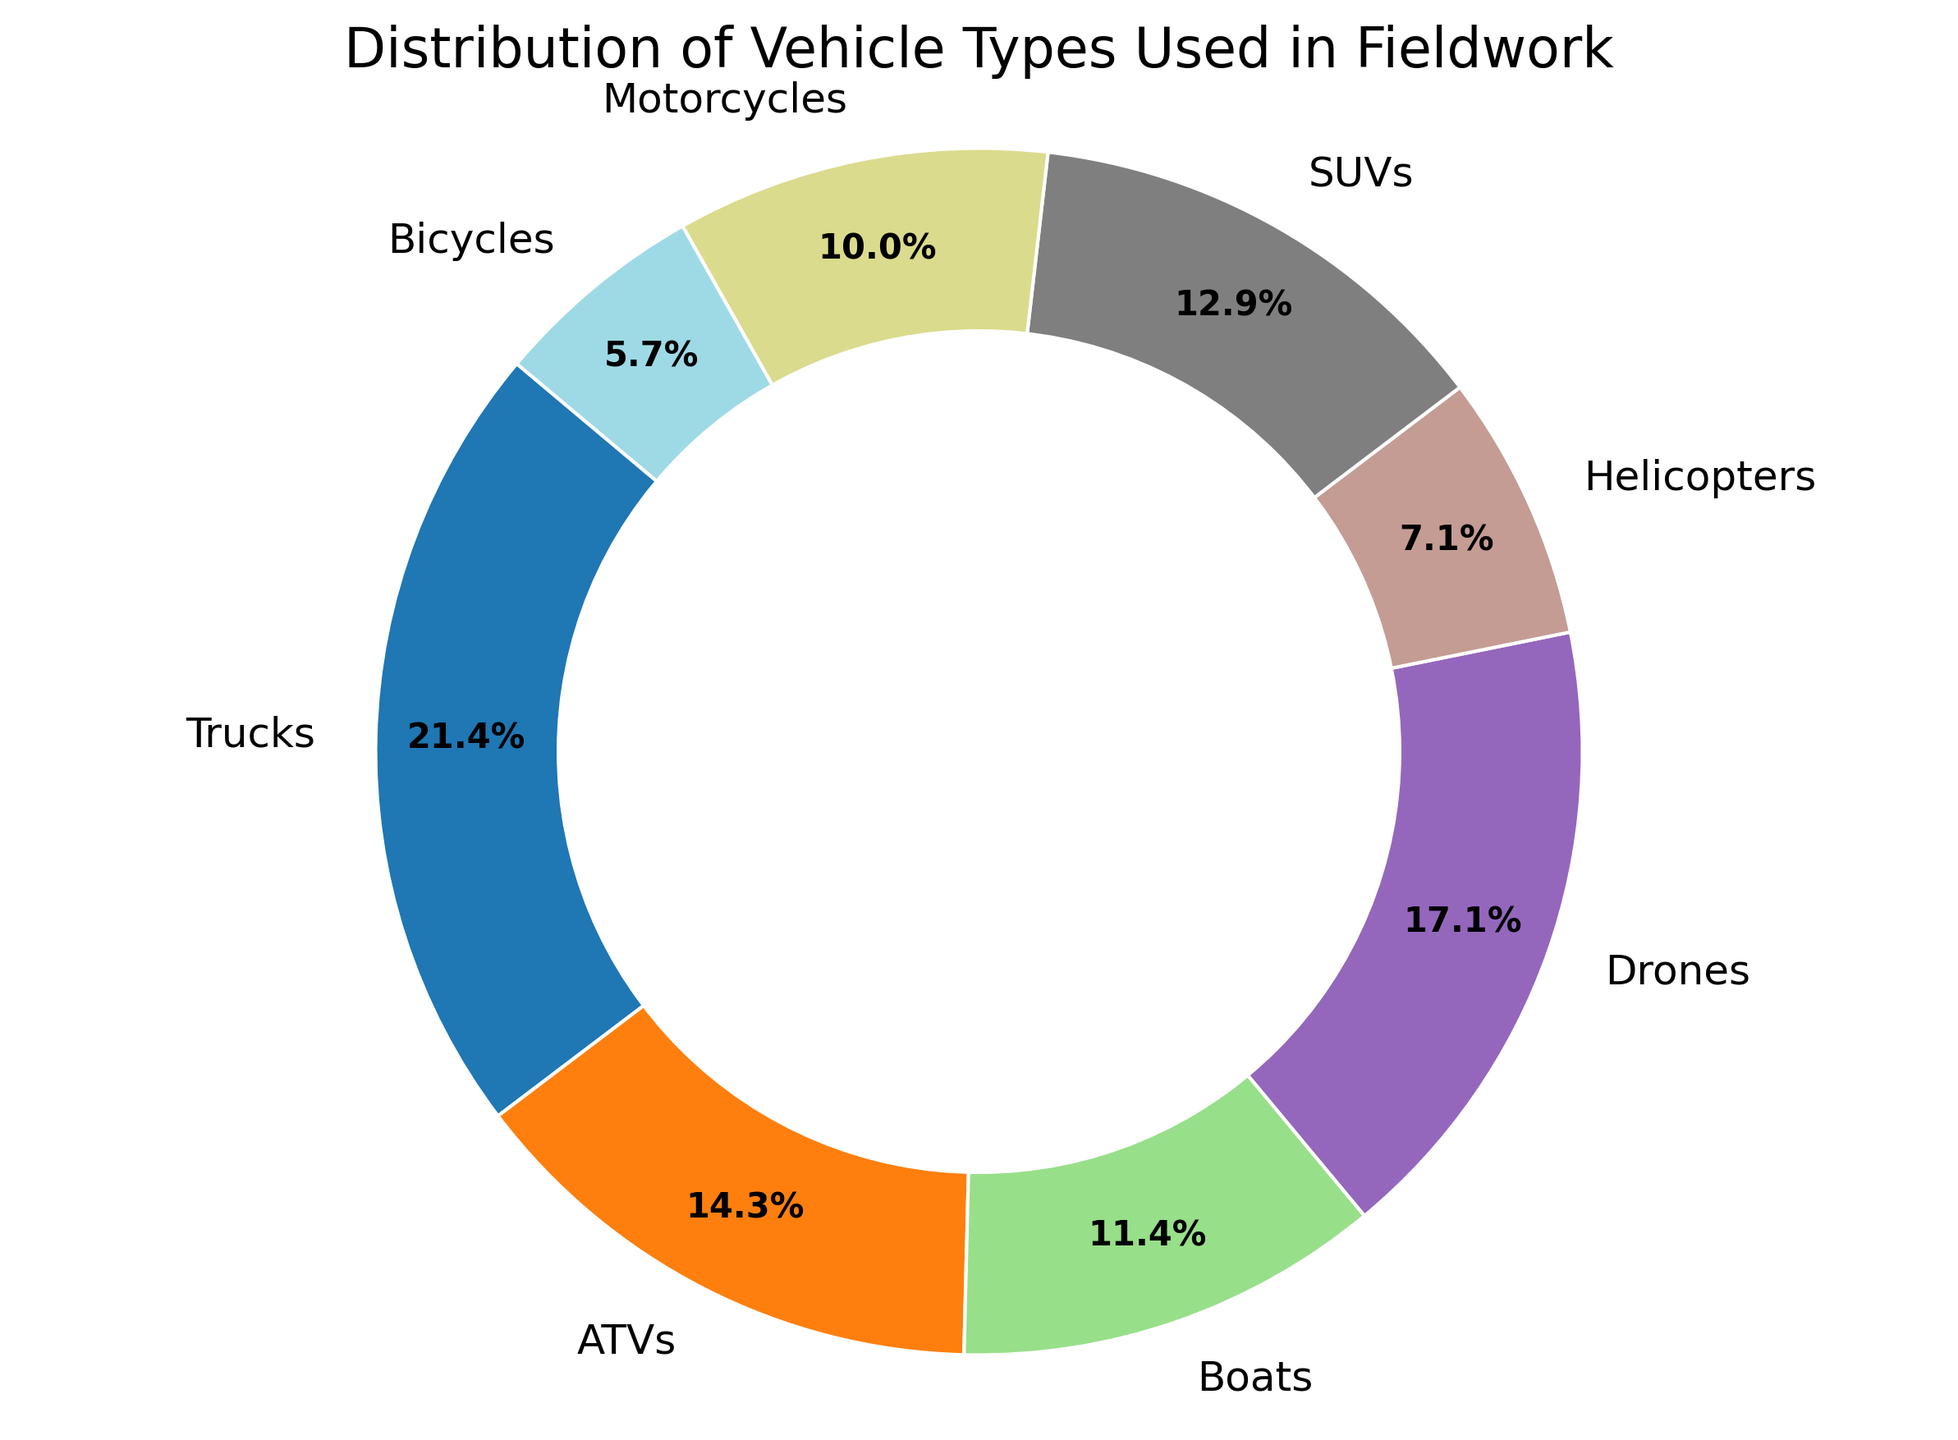What vehicle type is the most used in fieldwork? The pie chart displays the distribution of different vehicle types by percentage. The segment with the highest percentage represents the most-used vehicle type. The "Trucks" segment has the largest percentage (27.8%).
Answer: Trucks Which vehicle type is the least used in fieldwork? The pie chart displays the distribution of different vehicle types by percentage. The segment with the smallest percentage represents the least-used vehicle type. The "Bicycles" segment has the smallest percentage (7.4%).
Answer: Bicycles Do ATVs and Drones together make up more usage compared to Trucks alone? Add the percentages for ATVs and Drones: ATVs are 18.5%, and Drones are 22.2%. Together, they make up 18.5% + 22.2% = 40.7%. Trucks alone make up 27.8%. Since 40.7% is greater than 27.8%, ATVs and Drones together have more usage compared to Trucks alone.
Answer: Yes What is the total usage percentage of vehicles specifically used for off-road (ATVs and Motorcycles)? Add the percentages for ATVs and Motorcycles: ATVs are 18.5%, and Motorcycles are 13.0%. So, the total usage percentage for off-road vehicles is 18.5% + 13.0% = 31.5%.
Answer: 31.5% Are SUVs used more than Boats in fieldwork? Compare the percentages for SUVs and Boats: SUVs are 16.7%, and Boats are 14.8%. Since 16.7% is greater than 14.8%, SUVs are used more than Boats.
Answer: Yes Which vehicle type has a usage closest to 10%? Identify the vehicle type with a usage percentage nearest to 10% from the pie chart. The "ATVs" segment is at 18.5%, and the "SUVs" segment is at 16.7%. No vehicle type is exactly 10%, but "Boats" at 14.8% and "Helicopters" at 9.3% are the closest values. "Boats" is somewhat closer, but "Helicopters" are closer at exactly 9.3%.
Answer: Helicopters What is the combined usage percentage of Helicopters, SUVs, and Bicycles? Add the percentages for Helicopters, SUVs, and Bicycles: Helicopters are 9.3%, SUVs are 16.7%, and Bicycles are 7.4%. So, the combined usage percentage is 9.3% + 16.7% + 7.4% = 33.4%.
Answer: 33.4% Do all aerial vehicles (Drones and Helicopters) together account for more than one-third of the usage? Add the percentages for Drones and Helicopters: Drones are 22.2%, and Helicopters are 9.3%. Together, they make up 22.2% + 9.3% = 31.5%. Since 31.5% is less than 33.3%, they do not make up more than one-third.
Answer: No What is the sum of the percentages of land vehicles used (Trucks, ATVs, SUVs, Motorcycles, Bicycles)? Add the percentages for Trucks, ATVs, SUVs, Motorcycles, and Bicycles: Trucks are 27.8%, ATVs are 18.5%, SUVs are 16.7%, Motorcycles are 13.0%, and Bicycles are 7.4%. The total percentage is 27.8% + 18.5% + 16.7% + 13.0% + 7.4% = 83.4%.
Answer: 83.4% What is the percentage difference between the usage of Trucks and Drones? Subtract the percentage of Drones from the percentage of Trucks: Trucks are at 27.8%, and Drones are at 22.2%. The difference is 27.8% - 22.2% = 5.6%.
Answer: 5.6% 